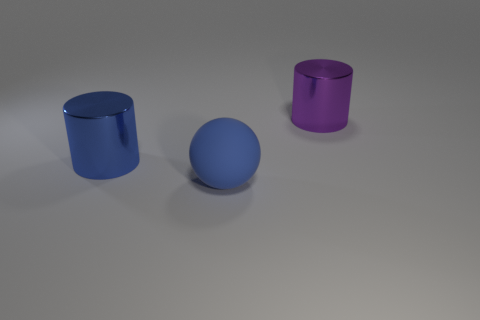Add 1 purple cylinders. How many objects exist? 4 Subtract all cylinders. How many objects are left? 1 Subtract all purple cylinders. How many cylinders are left? 1 Subtract 2 cylinders. How many cylinders are left? 0 Add 2 balls. How many balls are left? 3 Add 2 big objects. How many big objects exist? 5 Subtract 0 cyan cylinders. How many objects are left? 3 Subtract all brown cylinders. Subtract all cyan balls. How many cylinders are left? 2 Subtract all yellow matte blocks. Subtract all large purple shiny cylinders. How many objects are left? 2 